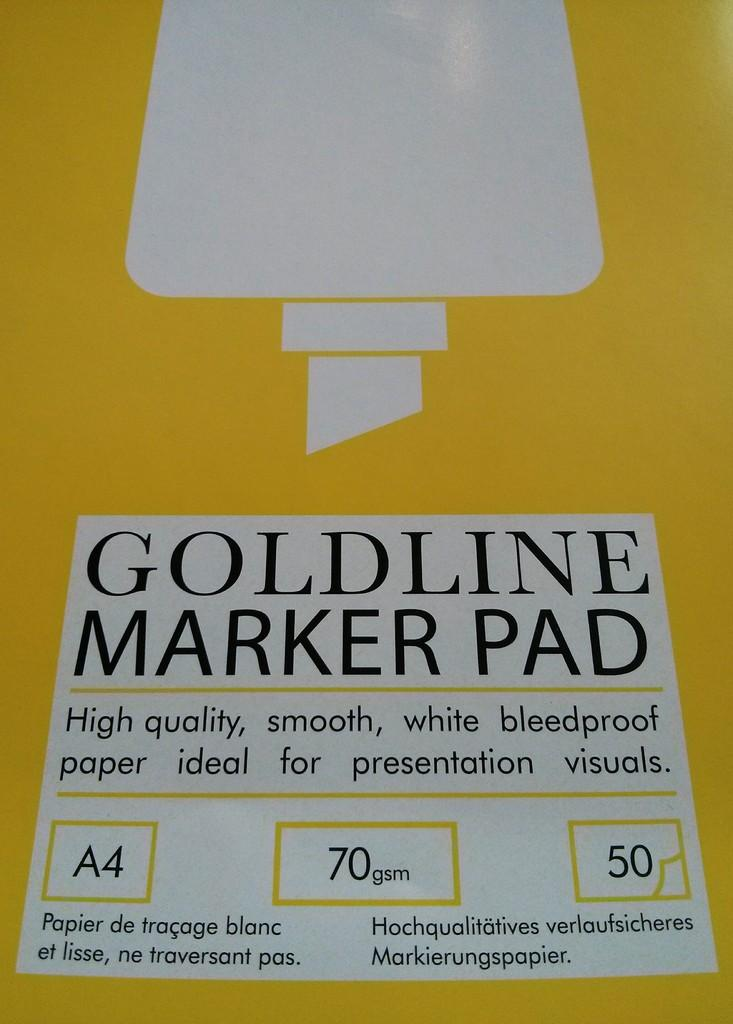Provide a one-sentence caption for the provided image. Closeup of Goldline Marker pad that includes bleedproof paper. 